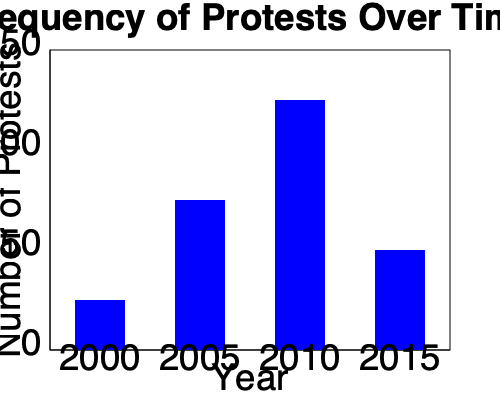Based on the histogram showing the frequency of protests over time, what trend can be observed, and how might this information be interpreted from a perspective critical of civil disobedience? To answer this question, we need to analyze the histogram and interpret it from a perspective critical of civil disobedience:

1. Observe the trend:
   - 2000: Approximately 25 protests
   - 2005: Approximately 75 protests
   - 2010: Approximately 125 protests
   - 2015: Approximately 50 protests

2. Identify the overall pattern:
   The number of protests increased from 2000 to 2010, reaching a peak in 2010, then decreased in 2015.

3. Interpret from a perspective critical of civil disobedience:
   a) The increase in protests from 2000 to 2010 could be seen as a rise in social unrest and disregard for established legal processes.
   b) The peak in 2010 might be interpreted as a climax of disruptive behavior that potentially undermined social order and the rule of law.
   c) The decrease in 2015 could be viewed positively as a return to more conventional and lawful means of political expression.

4. Consider potential negative impacts:
   - Increased protests may lead to public disturbances, property damage, and strain on law enforcement resources.
   - The trend might indicate a growing disrespect for authority and established democratic processes.

5. Conclusion:
   From a perspective critical of civil disobedience, this trend could be interpreted as a concerning rise in unlawful behavior that peaked in 2010, potentially threatening social stability and the proper functioning of democratic institutions.
Answer: Concerning rise in unlawful behavior peaking in 2010, threatening social stability and democratic processes. 